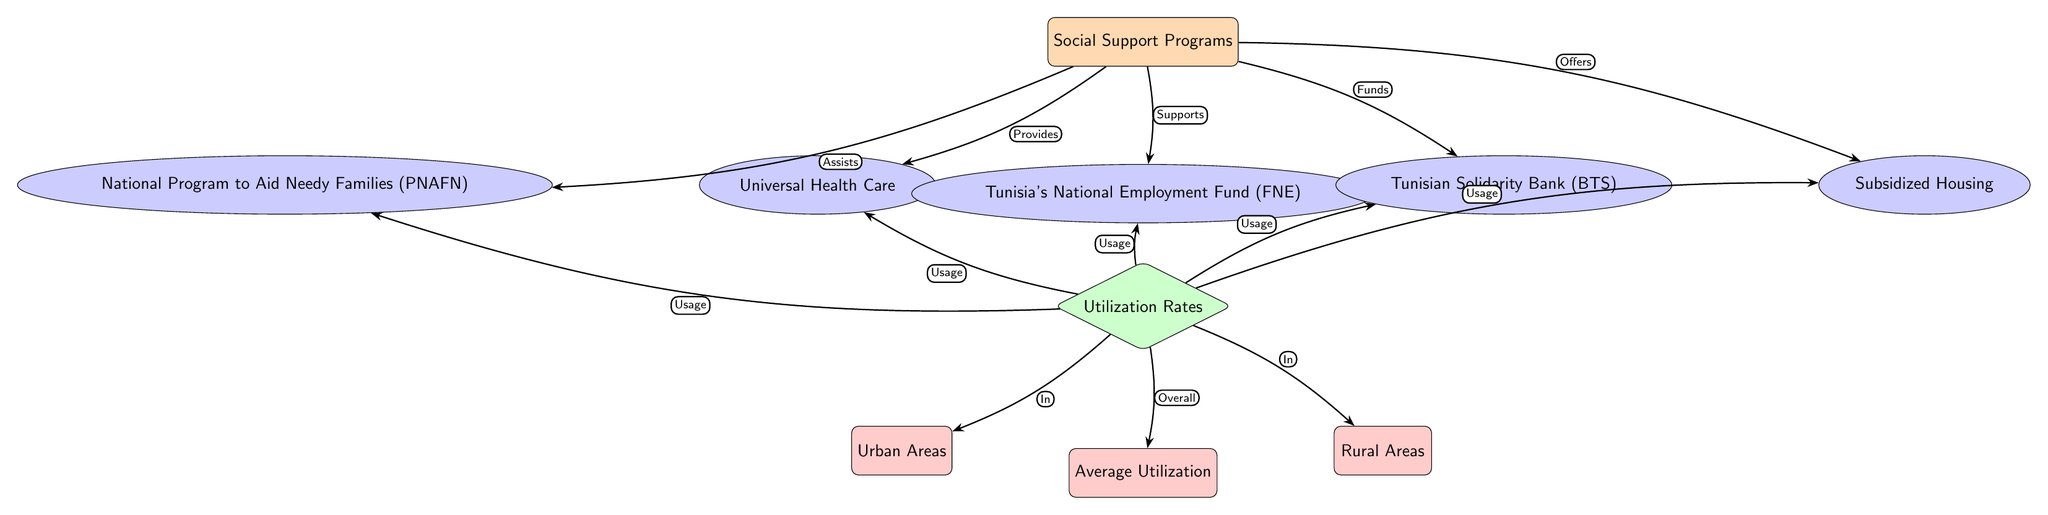What are the social support programs listed in the diagram? The diagram lists five social support programs, which are Universal Health Care, Tunisia's National Employment Fund (FNE), Tunisian Solidarity Bank (BTS), National Program to Aid Needy Families (PNAFN), and Subsidized Housing.
Answer: Universal Health Care, Tunisia's National Employment Fund (FNE), Tunisian Solidarity Bank (BTS), National Program to Aid Needy Families (PNAFN), Subsidized Housing How many social support programs are shown? The diagram shows a total of five distinct social support programs connected to the main node.
Answer: 5 What area does the utilization rate for social support programs refer to? The utilization rates in the diagram refer to two specific areas: Urban Areas and Rural Areas, reflecting where the usage occurs.
Answer: Urban Areas and Rural Areas Which program is associated with the lowest utilization in rural areas? To answer this, one would need to look for a specific program connected to the "Utilization Rates" node and the "Rural Areas" node to understand the performance in those areas; however, the diagram does not provide explicit utilization numbers.
Answer: Not specified What type of relationship exists between the main node and the Universal Health Care node? The diagram indicates that the connection between the main node (Social Support Programs) and the Universal Health Care node is categorized by the word "Provides," showing a supportive relationship.
Answer: Provides How does the Tunisian Solidarity Bank (BTS) contribute to overall social support? The diagram states that the Tunisian Solidarity Bank (BTS) "Funds" social support initiatives, indicating its financial role in supporting social services.
Answer: Funds What is indicated by the "Average Utilization" node? The "Average Utilization" node represents the overall utilization performance of all the social support programs indicated throughout the diagram across various communities.
Answer: Overall utilization Which node indicates the programs' usage in urban areas? The diagram connects the "Utilization Rates" node with another node labeled "Urban Areas," showing that it tracks the utilization for these specific programs within urban settings.
Answer: Urban Areas What kind of relationship is depicted between the National Program to Aid Needy Families (PNAFN) and social support programs? The diagram illustrates that the National Program to Aid Needy Families (PNAFN) "Assists" social support programs, indicating its role in providing aid.
Answer: Assists 